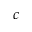<formula> <loc_0><loc_0><loc_500><loc_500>c</formula> 